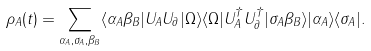<formula> <loc_0><loc_0><loc_500><loc_500>\rho _ { A } ( t ) = \sum _ { \alpha _ { A } , \sigma _ { A } , \beta _ { B } } \langle \alpha _ { A } \beta _ { B } | U _ { A } U _ { \partial } | \Omega \rangle \langle \Omega | U _ { A } ^ { \dag } U _ { \partial } ^ { \dag } | \sigma _ { A } \beta _ { B } \rangle | \alpha _ { A } \rangle \langle \sigma _ { A } | .</formula> 